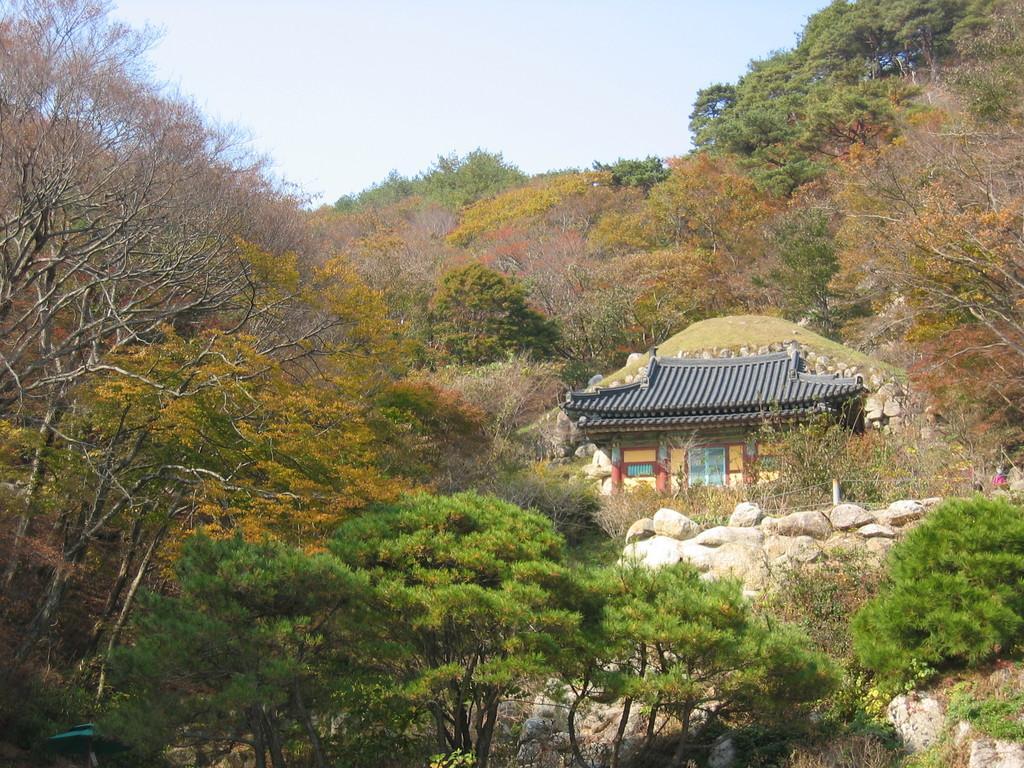Could you give a brief overview of what you see in this image? In this image I can see few trees,house,windows,doors,fencing and few stones. The sky is in blue and white color. 